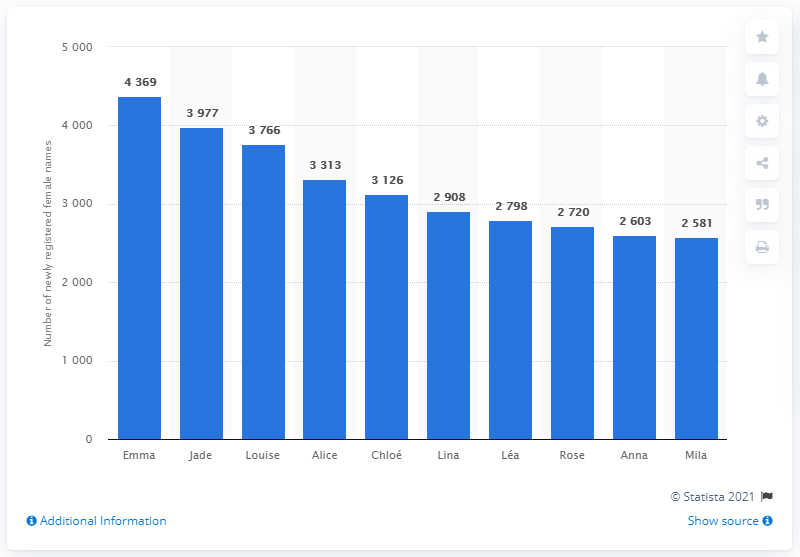Draw attention to some important aspects in this diagram. In 2018, the most popular name for girls was Emma. 